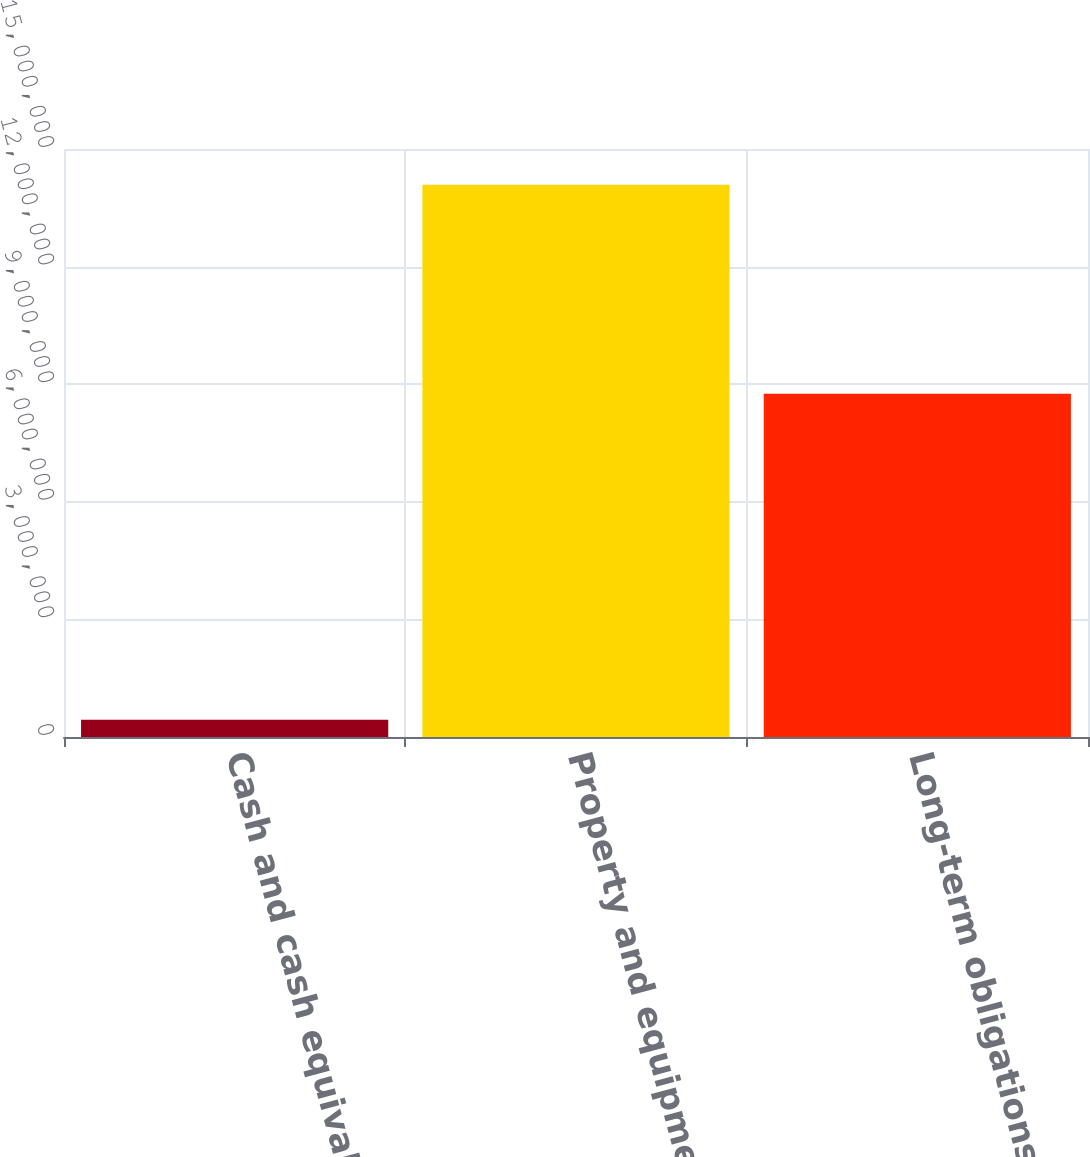<chart> <loc_0><loc_0><loc_500><loc_500><bar_chart><fcel>Cash and cash equivalents<fcel>Property and equipment net<fcel>Long-term obligations<nl><fcel>437934<fcel>1.40891e+07<fcel>8.75338e+06<nl></chart> 